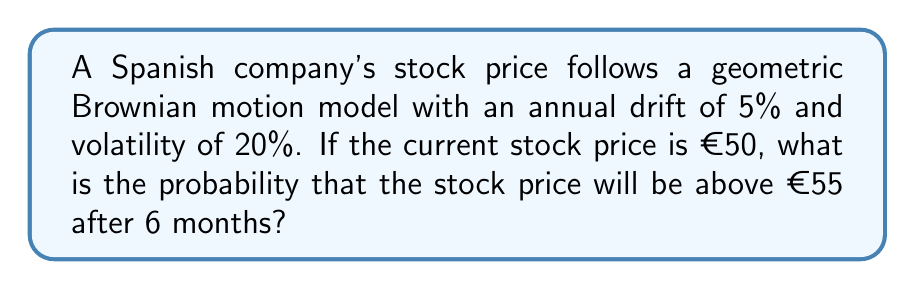Provide a solution to this math problem. Let's approach this step-by-step:

1) In a geometric Brownian motion model, the stock price $S_t$ at time $t$ is given by:

   $$S_t = S_0 \exp\left(\left(\mu - \frac{\sigma^2}{2}\right)t + \sigma W_t\right)$$

   Where $S_0$ is the initial price, $\mu$ is the drift, $\sigma$ is the volatility, and $W_t$ is a Wiener process.

2) The log returns are normally distributed with mean $\left(\mu - \frac{\sigma^2}{2}\right)t$ and variance $\sigma^2t$.

3) We need to find $P(S_t > 55)$ where $t = 0.5$ (6 months = 0.5 years).

4) This is equivalent to finding:

   $$P\left(\ln\left(\frac{S_t}{S_0}\right) > \ln\left(\frac{55}{50}\right)\right)$$

5) We can standardize this to a standard normal distribution:

   $$P\left(\frac{\ln\left(\frac{S_t}{S_0}\right) - \left(\mu - \frac{\sigma^2}{2}\right)t}{\sigma\sqrt{t}} > \frac{\ln\left(\frac{55}{50}\right) - \left(\mu - \frac{\sigma^2}{2}\right)t}{\sigma\sqrt{t}}\right)$$

6) Let's calculate the right side of the inequality:

   $$\frac{\ln(1.1) - (0.05 - \frac{0.2^2}{2})0.5}{0.2\sqrt{0.5}} \approx 0.0986$$

7) So, we need to find $P(Z > 0.0986)$ where $Z$ is a standard normal variable.

8) Using a standard normal table or calculator, we find:

   $$P(Z > 0.0986) \approx 0.4607$$

Therefore, the probability is approximately 0.4607 or 46.07%.
Answer: 0.4607 